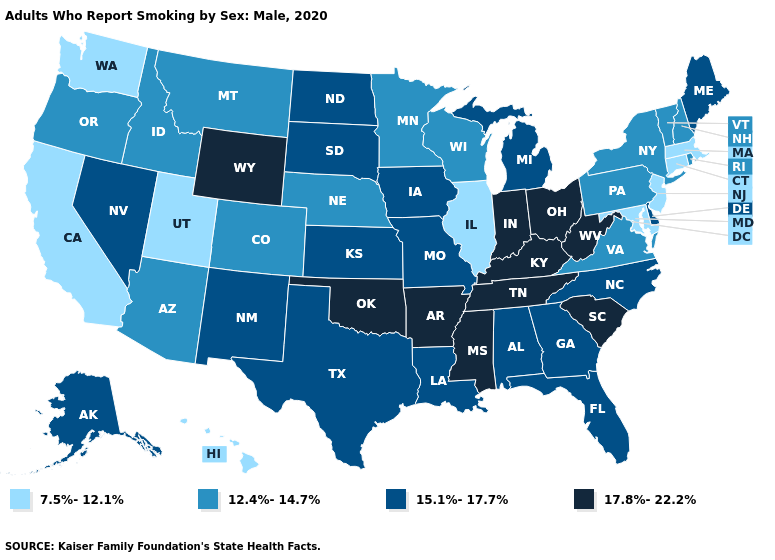What is the lowest value in the MidWest?
Be succinct. 7.5%-12.1%. What is the value of North Carolina?
Short answer required. 15.1%-17.7%. What is the highest value in states that border Maine?
Be succinct. 12.4%-14.7%. Does Colorado have the highest value in the West?
Answer briefly. No. Name the states that have a value in the range 15.1%-17.7%?
Short answer required. Alabama, Alaska, Delaware, Florida, Georgia, Iowa, Kansas, Louisiana, Maine, Michigan, Missouri, Nevada, New Mexico, North Carolina, North Dakota, South Dakota, Texas. Name the states that have a value in the range 7.5%-12.1%?
Quick response, please. California, Connecticut, Hawaii, Illinois, Maryland, Massachusetts, New Jersey, Utah, Washington. What is the value of Massachusetts?
Be succinct. 7.5%-12.1%. What is the value of Massachusetts?
Be succinct. 7.5%-12.1%. Which states hav the highest value in the South?
Short answer required. Arkansas, Kentucky, Mississippi, Oklahoma, South Carolina, Tennessee, West Virginia. Which states have the lowest value in the South?
Write a very short answer. Maryland. Does Minnesota have the same value as New Hampshire?
Answer briefly. Yes. Name the states that have a value in the range 7.5%-12.1%?
Give a very brief answer. California, Connecticut, Hawaii, Illinois, Maryland, Massachusetts, New Jersey, Utah, Washington. Name the states that have a value in the range 12.4%-14.7%?
Concise answer only. Arizona, Colorado, Idaho, Minnesota, Montana, Nebraska, New Hampshire, New York, Oregon, Pennsylvania, Rhode Island, Vermont, Virginia, Wisconsin. Among the states that border Rhode Island , which have the lowest value?
Give a very brief answer. Connecticut, Massachusetts. What is the value of Montana?
Quick response, please. 12.4%-14.7%. 